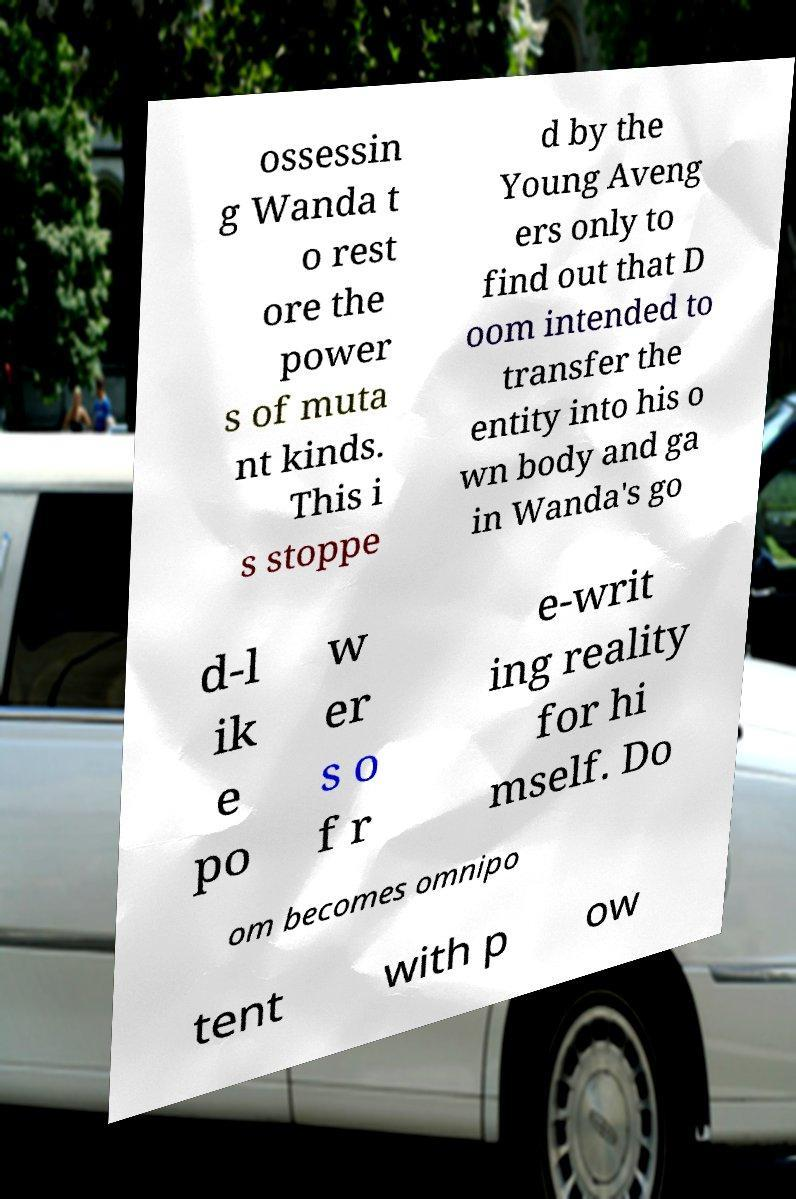For documentation purposes, I need the text within this image transcribed. Could you provide that? ossessin g Wanda t o rest ore the power s of muta nt kinds. This i s stoppe d by the Young Aveng ers only to find out that D oom intended to transfer the entity into his o wn body and ga in Wanda's go d-l ik e po w er s o f r e-writ ing reality for hi mself. Do om becomes omnipo tent with p ow 